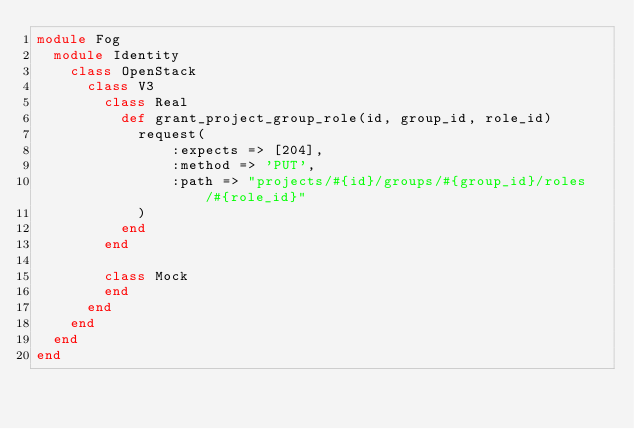<code> <loc_0><loc_0><loc_500><loc_500><_Ruby_>module Fog
  module Identity
    class OpenStack
      class V3
        class Real
          def grant_project_group_role(id, group_id, role_id)
            request(
                :expects => [204],
                :method => 'PUT',
                :path => "projects/#{id}/groups/#{group_id}/roles/#{role_id}"
            )
          end
        end

        class Mock
        end
      end
    end
  end
end</code> 